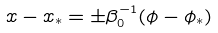Convert formula to latex. <formula><loc_0><loc_0><loc_500><loc_500>x - x _ { * } = \pm \beta _ { 0 } ^ { - 1 } ( \phi - \phi _ { * } )</formula> 